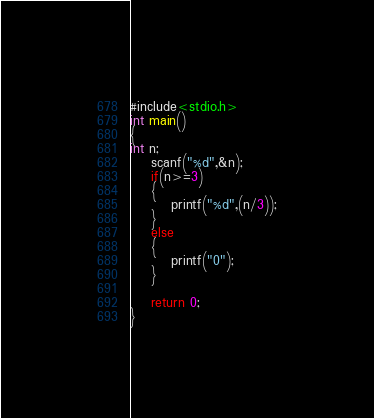<code> <loc_0><loc_0><loc_500><loc_500><_C_>#include<stdio.h>
int main()
{
int n;
    scanf("%d",&n);
    if(n>=3)
    {
        printf("%d",(n/3));
    }
    else
    {
        printf("0");
    }

    return 0;
}</code> 